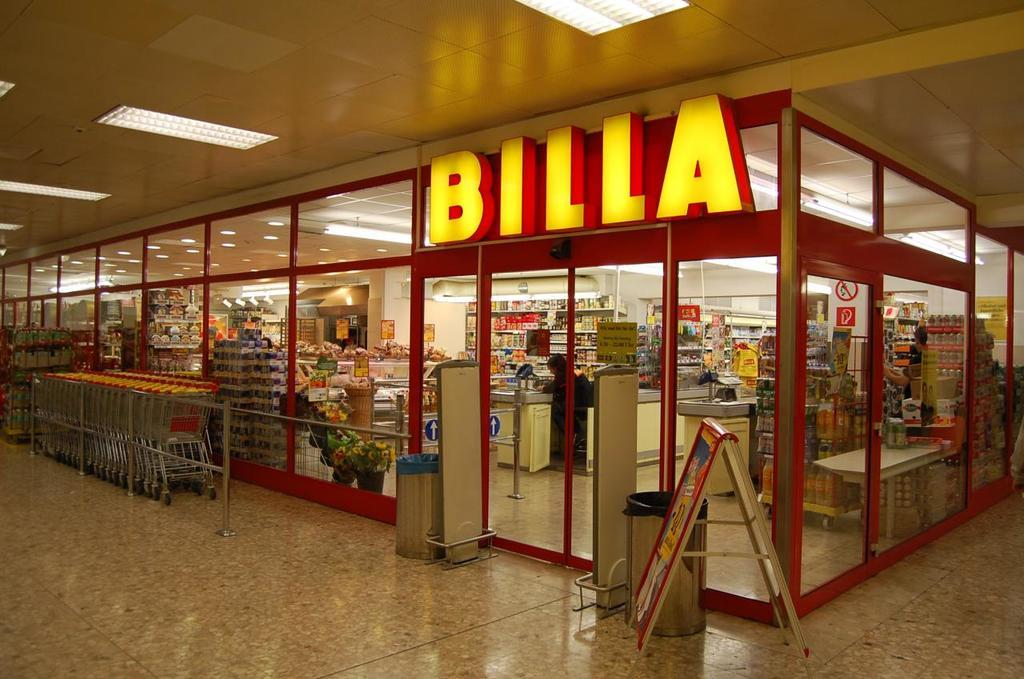<image>
Provide a brief description of the given image. The exterior of a Billa supermarket within a shopping mall. 